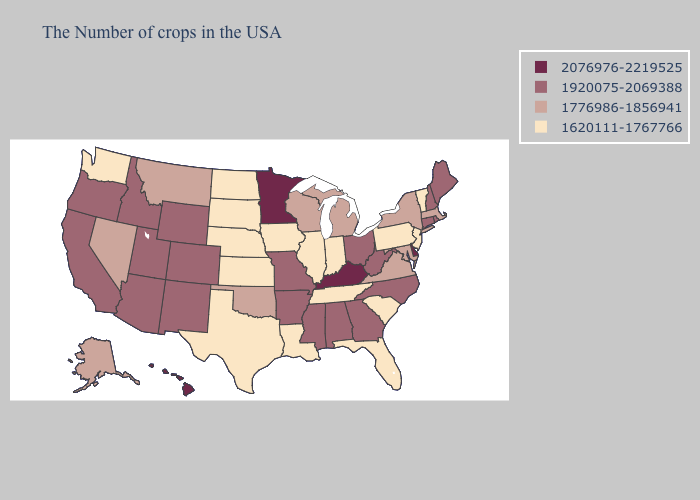Is the legend a continuous bar?
Quick response, please. No. Does Oklahoma have the lowest value in the USA?
Give a very brief answer. No. What is the lowest value in states that border Mississippi?
Keep it brief. 1620111-1767766. What is the value of California?
Answer briefly. 1920075-2069388. Does the first symbol in the legend represent the smallest category?
Quick response, please. No. What is the lowest value in states that border Maine?
Short answer required. 1920075-2069388. Among the states that border Delaware , which have the highest value?
Give a very brief answer. Maryland. What is the lowest value in the West?
Be succinct. 1620111-1767766. Name the states that have a value in the range 1920075-2069388?
Write a very short answer. Maine, Rhode Island, New Hampshire, Connecticut, North Carolina, West Virginia, Ohio, Georgia, Alabama, Mississippi, Missouri, Arkansas, Wyoming, Colorado, New Mexico, Utah, Arizona, Idaho, California, Oregon. Does the first symbol in the legend represent the smallest category?
Write a very short answer. No. How many symbols are there in the legend?
Write a very short answer. 4. What is the value of New York?
Give a very brief answer. 1776986-1856941. Is the legend a continuous bar?
Keep it brief. No. Which states have the lowest value in the USA?
Write a very short answer. Vermont, New Jersey, Pennsylvania, South Carolina, Florida, Indiana, Tennessee, Illinois, Louisiana, Iowa, Kansas, Nebraska, Texas, South Dakota, North Dakota, Washington. Which states have the lowest value in the USA?
Short answer required. Vermont, New Jersey, Pennsylvania, South Carolina, Florida, Indiana, Tennessee, Illinois, Louisiana, Iowa, Kansas, Nebraska, Texas, South Dakota, North Dakota, Washington. 